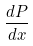<formula> <loc_0><loc_0><loc_500><loc_500>\frac { d P } { d x }</formula> 